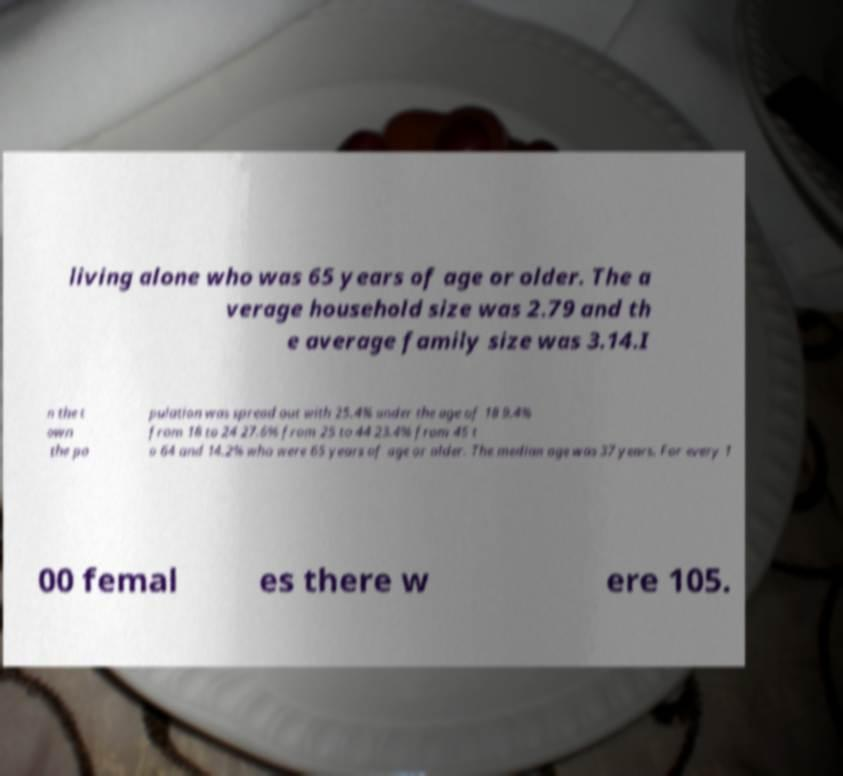What messages or text are displayed in this image? I need them in a readable, typed format. living alone who was 65 years of age or older. The a verage household size was 2.79 and th e average family size was 3.14.I n the t own the po pulation was spread out with 25.4% under the age of 18 9.4% from 18 to 24 27.6% from 25 to 44 23.4% from 45 t o 64 and 14.2% who were 65 years of age or older. The median age was 37 years. For every 1 00 femal es there w ere 105. 